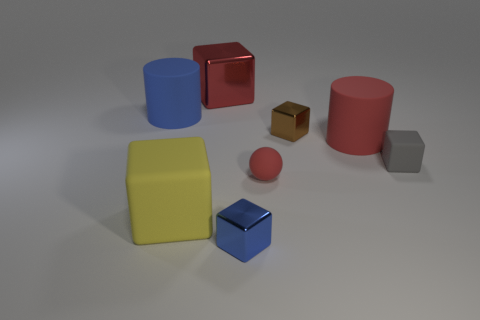There is another matte cylinder that is the same size as the red rubber cylinder; what color is it?
Your response must be concise. Blue. Is there a big matte block of the same color as the sphere?
Offer a terse response. No. Does the shiny object right of the blue metal object have the same shape as the blue object that is on the left side of the blue block?
Keep it short and to the point. No. The metallic block that is the same color as the tiny sphere is what size?
Your answer should be very brief. Large. What number of other things are the same size as the yellow thing?
Make the answer very short. 3. There is a big shiny block; does it have the same color as the small shiny object to the right of the blue metallic thing?
Offer a very short reply. No. Is the number of things behind the large yellow block less than the number of red shiny blocks that are to the right of the small red rubber object?
Your answer should be compact. No. What is the color of the object that is to the right of the big blue rubber cylinder and behind the tiny brown thing?
Your answer should be very brief. Red. Does the yellow rubber cube have the same size as the metallic cube that is behind the blue cylinder?
Keep it short and to the point. Yes. There is a large red object that is right of the tiny blue thing; what is its shape?
Give a very brief answer. Cylinder. 